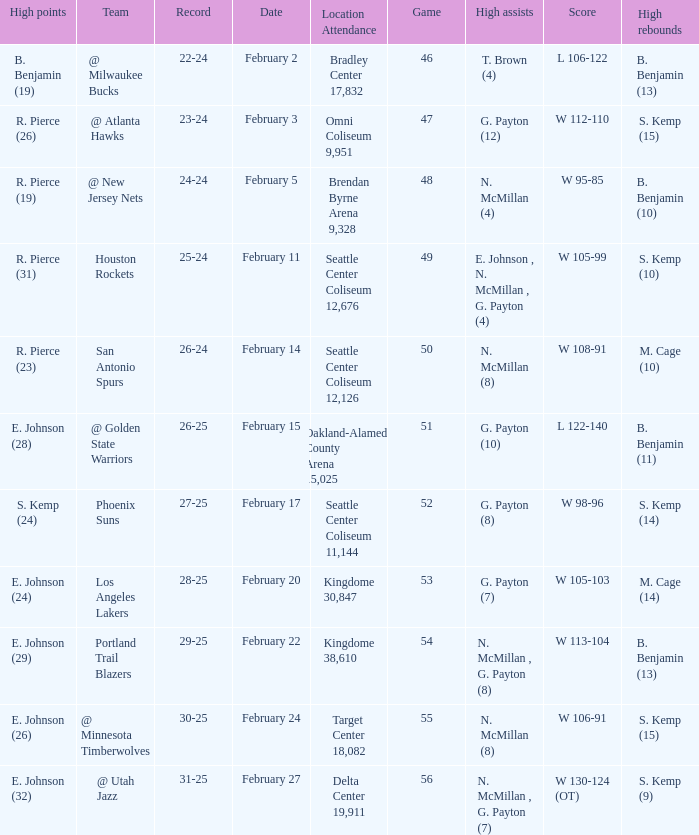Who had the high points when the score was w 112-110? R. Pierce (26). 